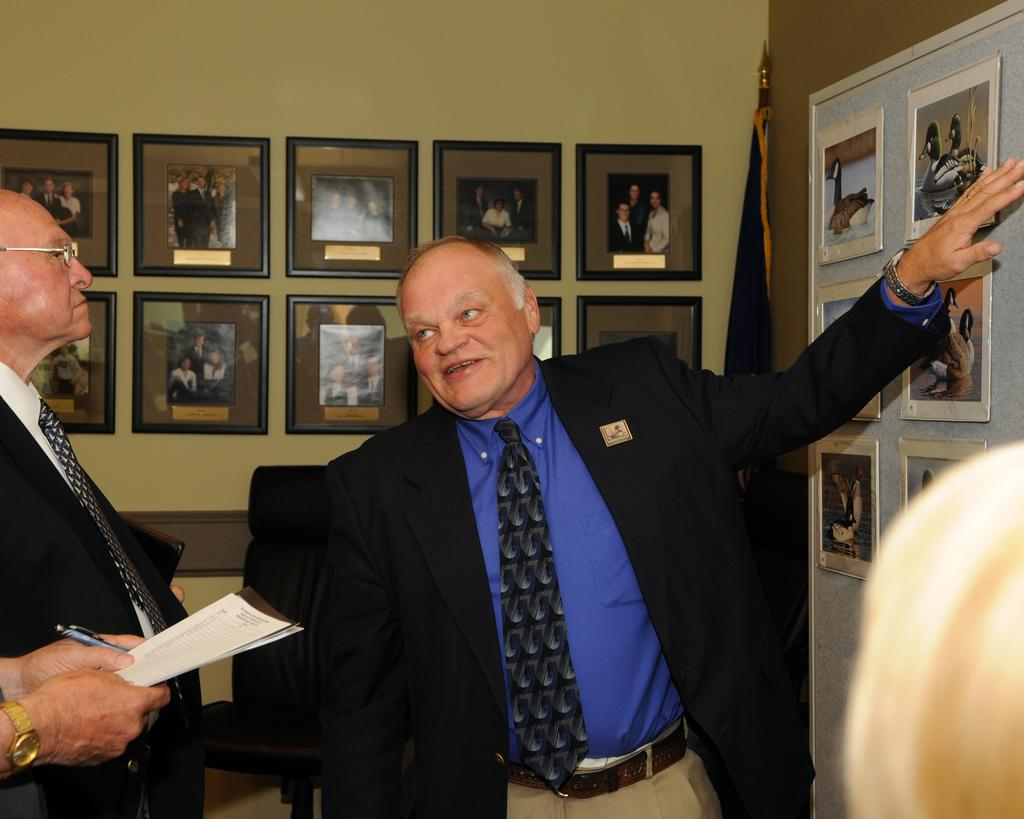What is happening in the image? There are people standing in the image. What can be seen in the background of the image? There are photo frames in the background of the image. Where are the photo frames located in the image? There are photo frames on the right side of the image. What type of yak can be seen in the image? There is no yak present in the image. What sense is being used by the people in the image? The provided facts do not give information about the senses being used by the people in the image. 